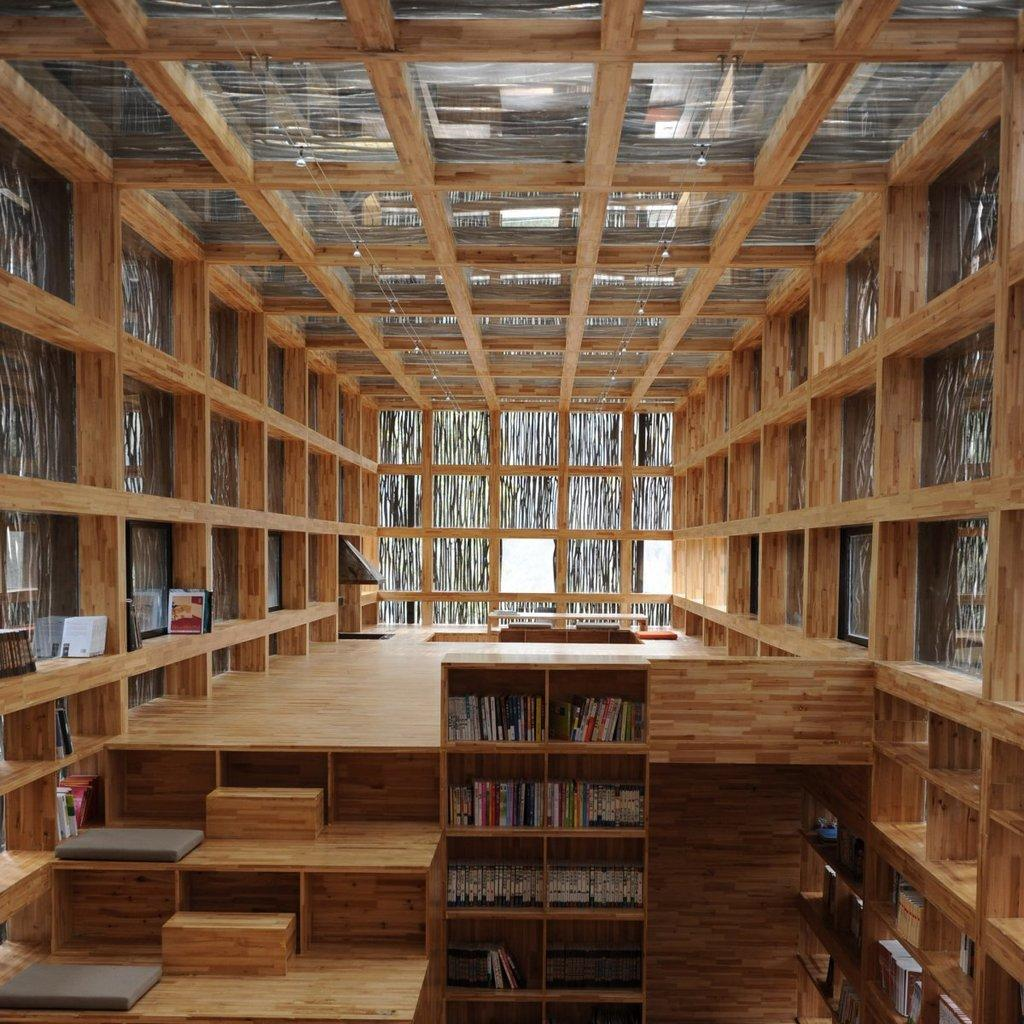What type of storage is being used for the books in the image? The books are stored in wooden racks in the image. Can you describe the objects on the tables in the image? Unfortunately, the facts provided do not give any details about the objects on the tables. However, we can see that there are objects present on the tables. What type of experience can be gained from the base in the image? There is no base present in the image, and therefore no experience can be gained from it. 